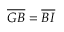Convert formula to latex. <formula><loc_0><loc_0><loc_500><loc_500>\overline { G B } = \overline { B I }</formula> 